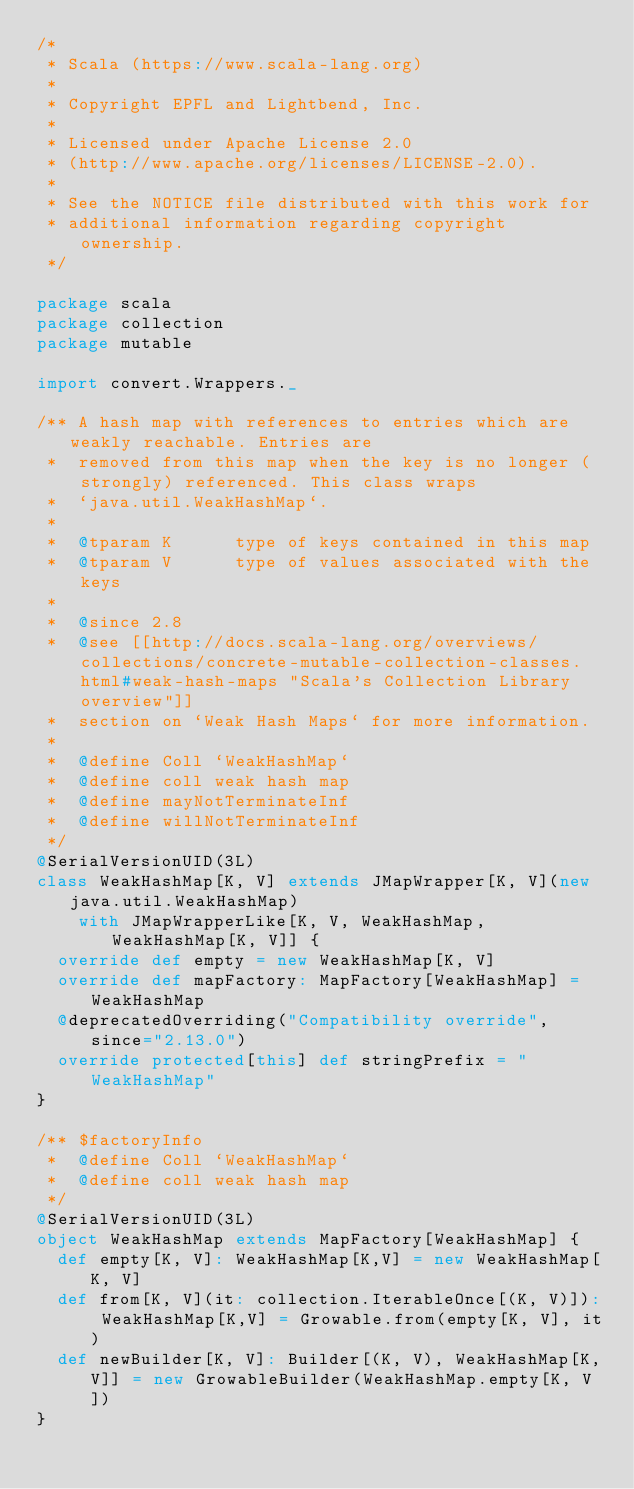Convert code to text. <code><loc_0><loc_0><loc_500><loc_500><_Scala_>/*
 * Scala (https://www.scala-lang.org)
 *
 * Copyright EPFL and Lightbend, Inc.
 *
 * Licensed under Apache License 2.0
 * (http://www.apache.org/licenses/LICENSE-2.0).
 *
 * See the NOTICE file distributed with this work for
 * additional information regarding copyright ownership.
 */

package scala
package collection
package mutable

import convert.Wrappers._

/** A hash map with references to entries which are weakly reachable. Entries are
 *  removed from this map when the key is no longer (strongly) referenced. This class wraps
 *  `java.util.WeakHashMap`.
 *
 *  @tparam K      type of keys contained in this map
 *  @tparam V      type of values associated with the keys
 *
 *  @since 2.8
 *  @see [[http://docs.scala-lang.org/overviews/collections/concrete-mutable-collection-classes.html#weak-hash-maps "Scala's Collection Library overview"]]
 *  section on `Weak Hash Maps` for more information.
 *
 *  @define Coll `WeakHashMap`
 *  @define coll weak hash map
 *  @define mayNotTerminateInf
 *  @define willNotTerminateInf
 */
@SerialVersionUID(3L)
class WeakHashMap[K, V] extends JMapWrapper[K, V](new java.util.WeakHashMap)
    with JMapWrapperLike[K, V, WeakHashMap, WeakHashMap[K, V]] {
  override def empty = new WeakHashMap[K, V]
  override def mapFactory: MapFactory[WeakHashMap] = WeakHashMap
  @deprecatedOverriding("Compatibility override", since="2.13.0")
  override protected[this] def stringPrefix = "WeakHashMap"
}

/** $factoryInfo
 *  @define Coll `WeakHashMap`
 *  @define coll weak hash map
 */
@SerialVersionUID(3L)
object WeakHashMap extends MapFactory[WeakHashMap] {
  def empty[K, V]: WeakHashMap[K,V] = new WeakHashMap[K, V]
  def from[K, V](it: collection.IterableOnce[(K, V)]): WeakHashMap[K,V] = Growable.from(empty[K, V], it)
  def newBuilder[K, V]: Builder[(K, V), WeakHashMap[K,V]] = new GrowableBuilder(WeakHashMap.empty[K, V])
}

</code> 